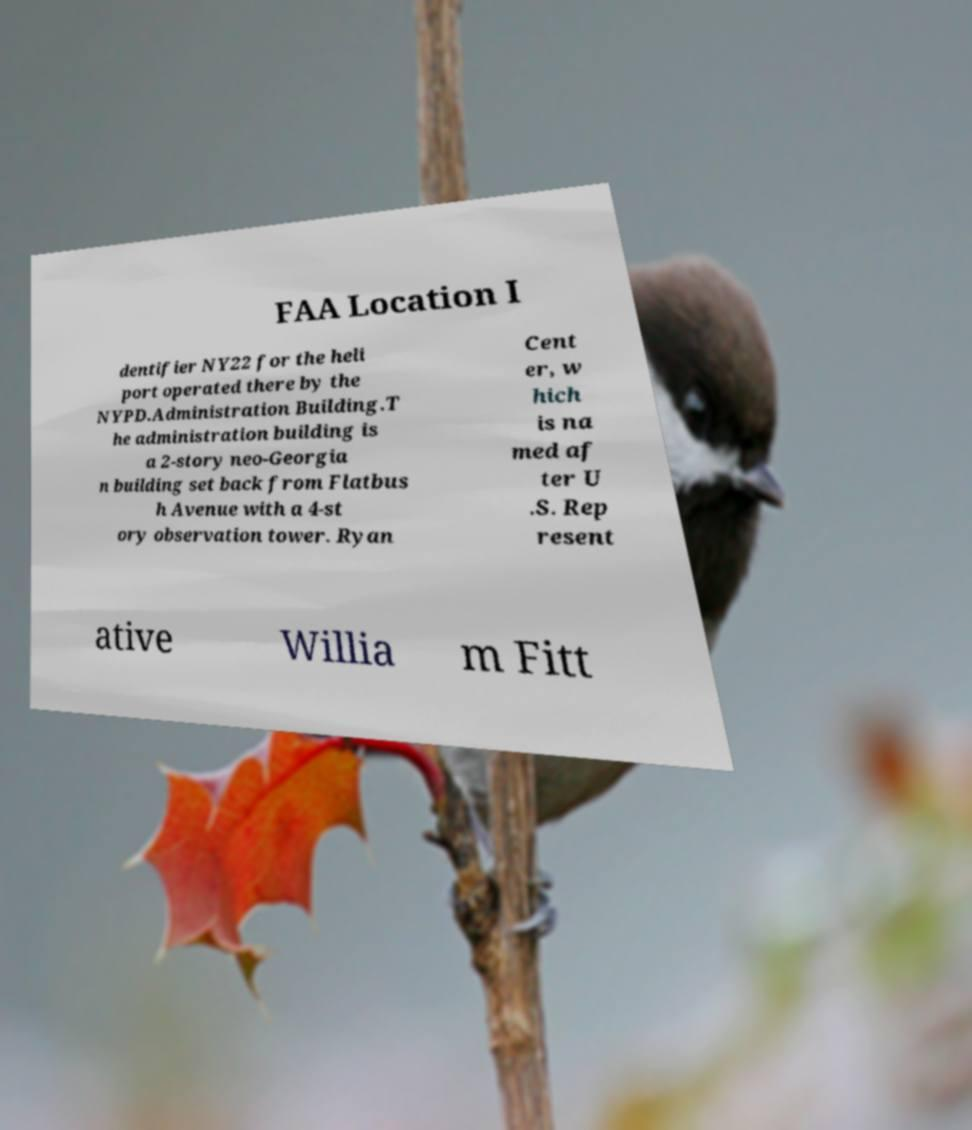Can you read and provide the text displayed in the image?This photo seems to have some interesting text. Can you extract and type it out for me? FAA Location I dentifier NY22 for the heli port operated there by the NYPD.Administration Building.T he administration building is a 2-story neo-Georgia n building set back from Flatbus h Avenue with a 4-st ory observation tower. Ryan Cent er, w hich is na med af ter U .S. Rep resent ative Willia m Fitt 